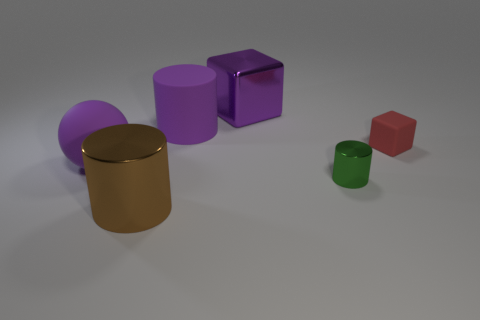Are there any other things that have the same shape as the brown shiny object?
Give a very brief answer. Yes. There is a big block that is the same color as the rubber cylinder; what is it made of?
Provide a succinct answer. Metal. Are there an equal number of red objects in front of the large brown metallic cylinder and tiny gray matte cylinders?
Ensure brevity in your answer.  Yes. There is a purple metallic object; are there any small red things in front of it?
Offer a terse response. Yes. There is a tiny red thing; is it the same shape as the large metal thing behind the green cylinder?
Your answer should be compact. Yes. The other cylinder that is made of the same material as the tiny cylinder is what color?
Your answer should be compact. Brown. The tiny matte cube has what color?
Make the answer very short. Red. Are the ball and the big cylinder that is behind the green cylinder made of the same material?
Your response must be concise. Yes. What number of rubber objects are both on the right side of the rubber sphere and to the left of the red rubber thing?
Give a very brief answer. 1. What shape is the red object that is the same size as the green metal cylinder?
Your answer should be compact. Cube. 